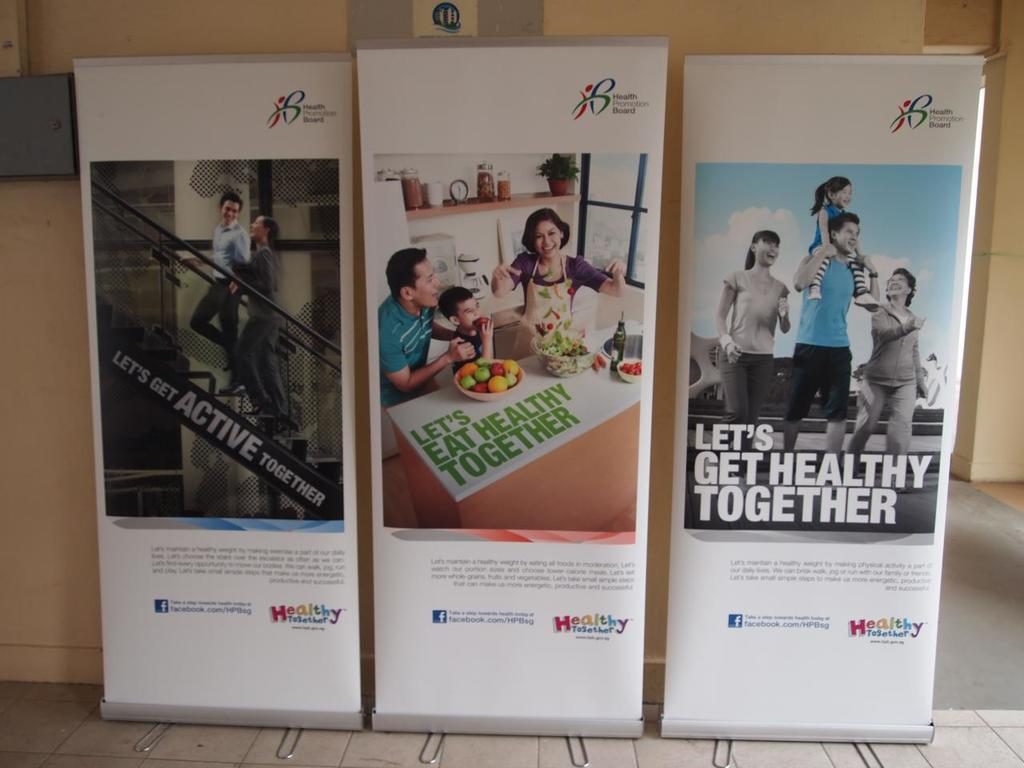<image>
Share a concise interpretation of the image provided. Three posters from the Health Promotion Board that say Let's get Active, Eat and get Healthy together. 